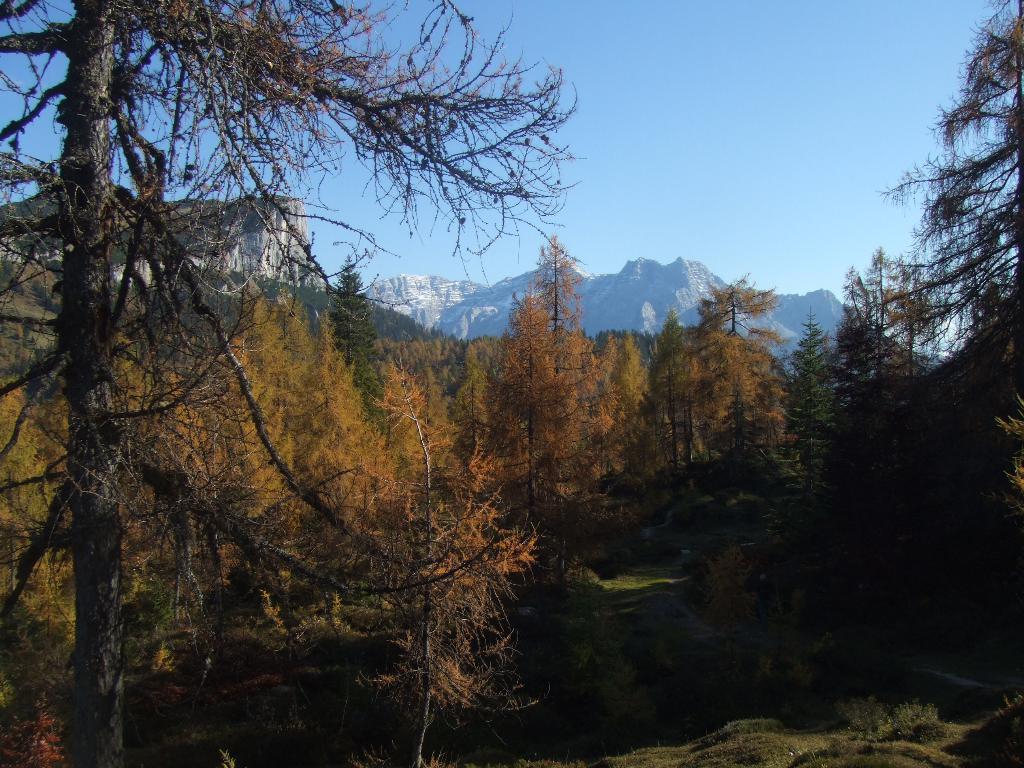Could you give a brief overview of what you see in this image? In this image I can see trees in green color, background I can see mountains, and the sky is in blue color. 